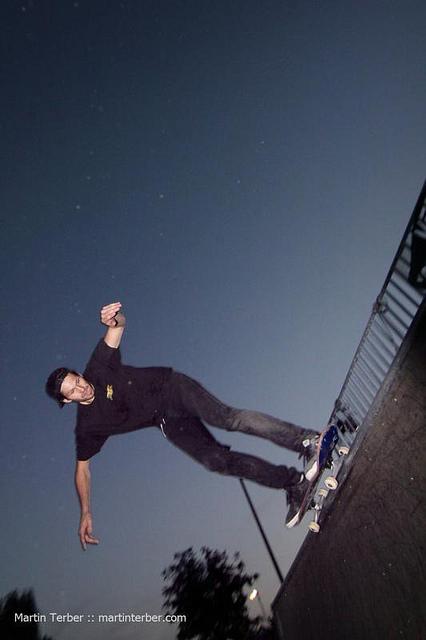Could a parent be taking a photo?
Keep it brief. No. What color is the person's shirt?
Be succinct. Black. What is he skateboarding on?
Quick response, please. Ramp. Is the sundown?
Keep it brief. Yes. What color is the ramp?
Give a very brief answer. Gray. What name is at the bottom?
Write a very short answer. Martin terber. What constellation can be seen in the sky?
Give a very brief answer. Big dipper. What sport is the man playing?
Be succinct. Skateboarding. Are both feet on the skateboard?
Quick response, please. Yes. What color is the boy on the ramps hat?
Keep it brief. Black. When is this taken?
Be succinct. Evening. Is the guy jumping off a bridge?
Concise answer only. No. What game is being played?
Give a very brief answer. Skateboarding. Is the skateboarder up high in the air?
Concise answer only. No. Are his feet on the skateboard?
Keep it brief. Yes. What is the man doing with his left hand?
Answer briefly. Balancing. How high is the man jumping?
Write a very short answer. 1 foot. Is there a building in this photo?
Concise answer only. No. Is he still on the skateboard?
Answer briefly. Yes. Where is the skateboard?
Give a very brief answer. Park. Why are the lights blurred?
Be succinct. Dusk. How many wheels on the skateboard are in the air?
Be succinct. 0. On what website can this picture be found?
Write a very short answer. Martinterbercom. Is this Tony Hawk?
Give a very brief answer. No. How many wheels are on the ground?
Short answer required. 0. What is the man standing on?
Write a very short answer. Skateboard. What sport is he playing?
Keep it brief. Skateboarding. Why is the guy jumping?
Concise answer only. Skateboarding. Which way is the picture rotated?
Write a very short answer. Left. Are the athlete's skating vert or street?
Concise answer only. Vert. What color is the man's shirt?
Short answer required. Black. What color is the boy?
Give a very brief answer. White. 